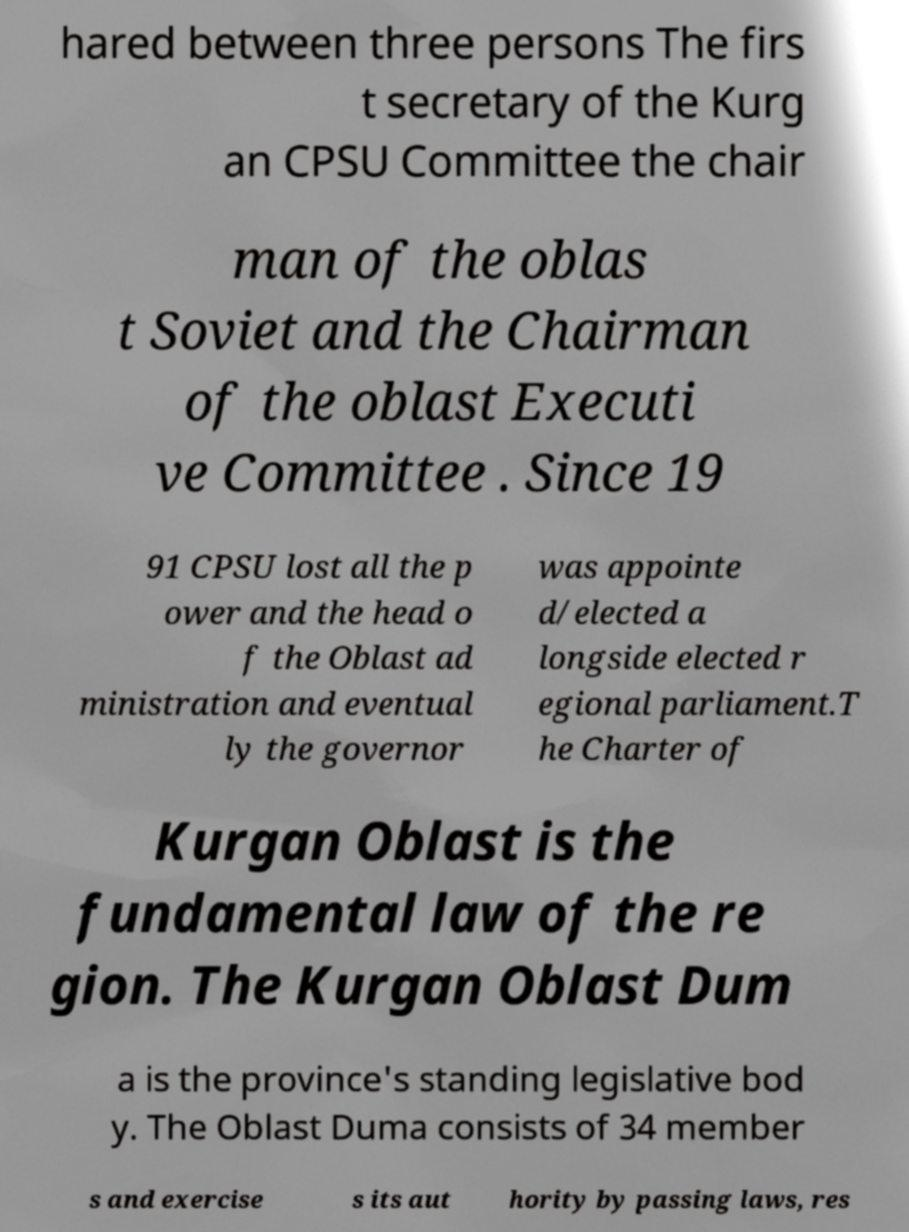There's text embedded in this image that I need extracted. Can you transcribe it verbatim? hared between three persons The firs t secretary of the Kurg an CPSU Committee the chair man of the oblas t Soviet and the Chairman of the oblast Executi ve Committee . Since 19 91 CPSU lost all the p ower and the head o f the Oblast ad ministration and eventual ly the governor was appointe d/elected a longside elected r egional parliament.T he Charter of Kurgan Oblast is the fundamental law of the re gion. The Kurgan Oblast Dum a is the province's standing legislative bod y. The Oblast Duma consists of 34 member s and exercise s its aut hority by passing laws, res 